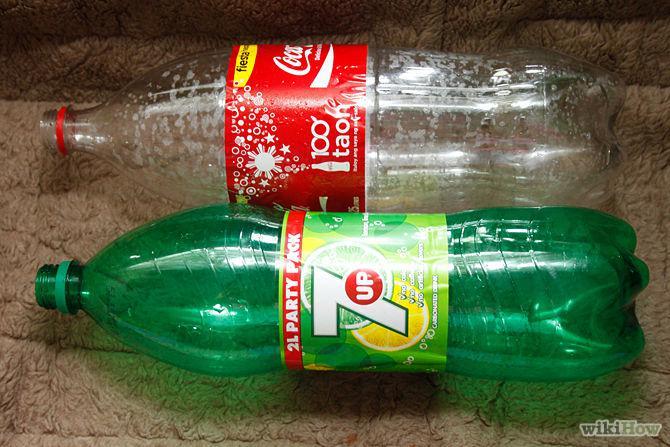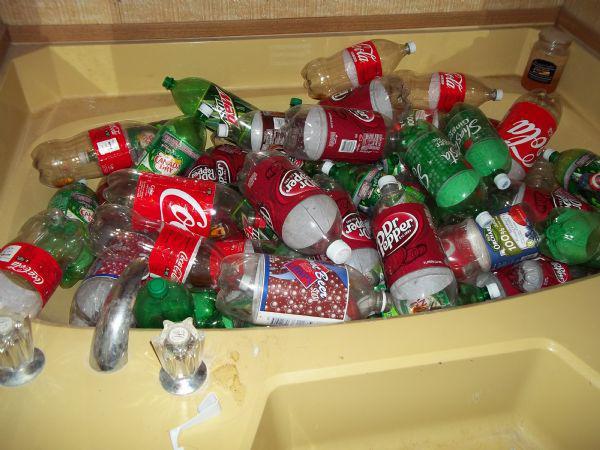The first image is the image on the left, the second image is the image on the right. Analyze the images presented: Is the assertion "Some bottles are cut open." valid? Answer yes or no. No. The first image is the image on the left, the second image is the image on the right. Examine the images to the left and right. Is the description "One of the images contains two or fewer bottles." accurate? Answer yes or no. Yes. 